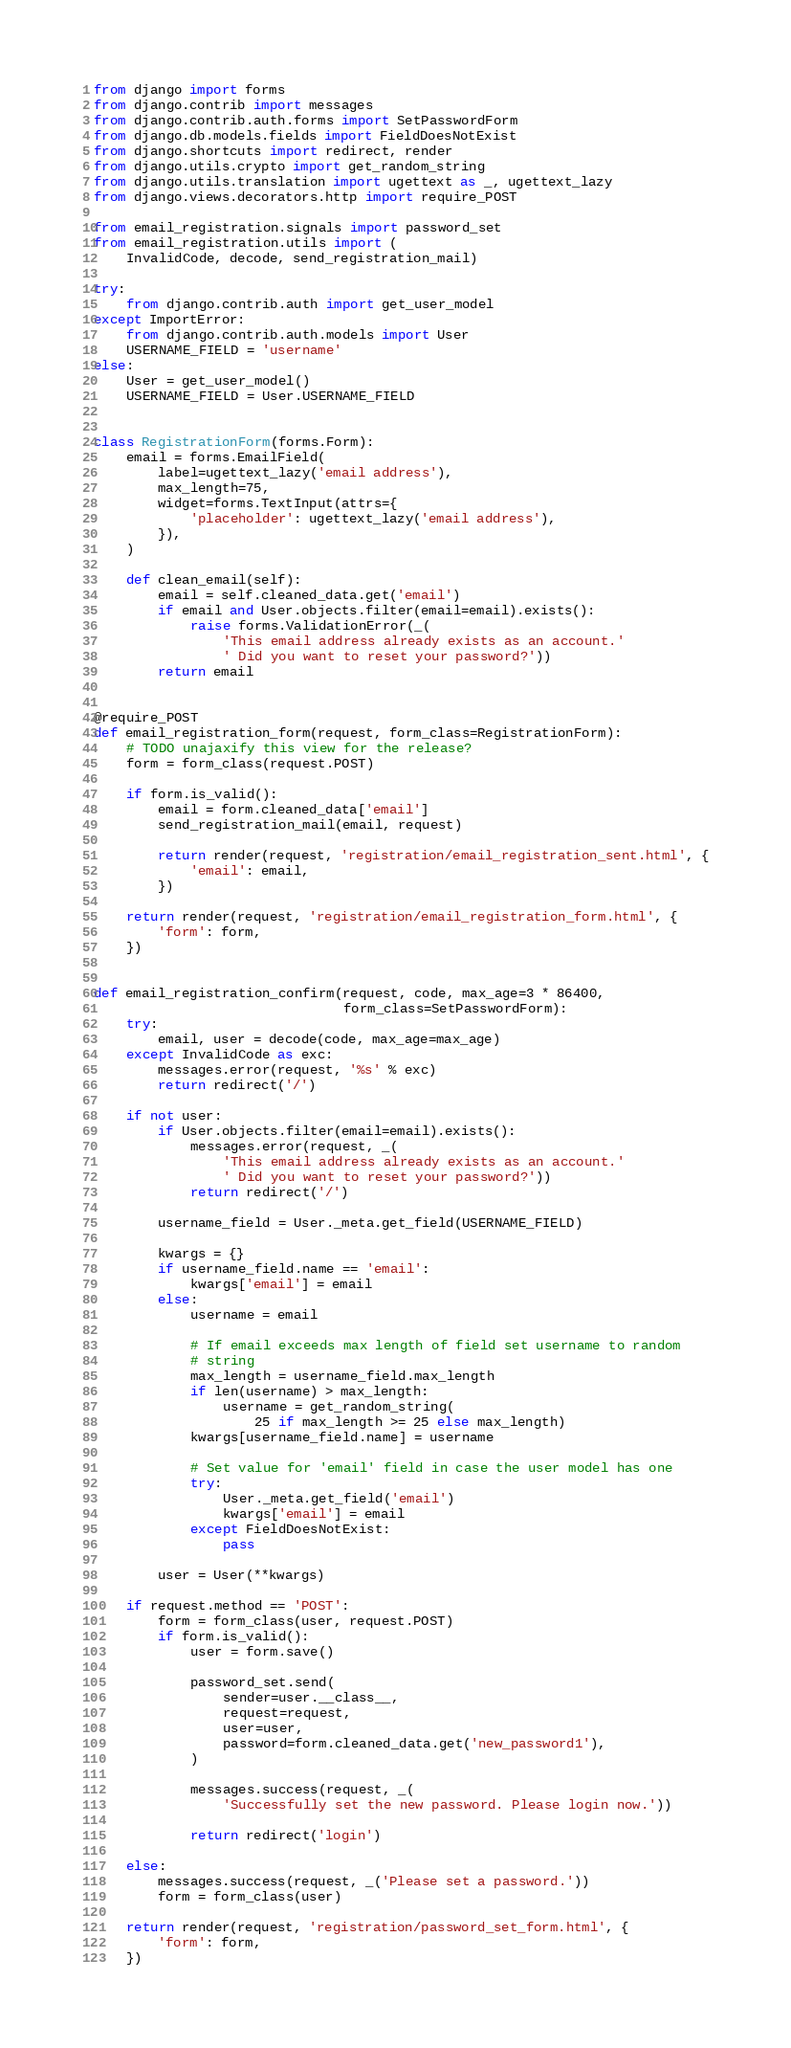<code> <loc_0><loc_0><loc_500><loc_500><_Python_>from django import forms
from django.contrib import messages
from django.contrib.auth.forms import SetPasswordForm
from django.db.models.fields import FieldDoesNotExist
from django.shortcuts import redirect, render
from django.utils.crypto import get_random_string
from django.utils.translation import ugettext as _, ugettext_lazy
from django.views.decorators.http import require_POST

from email_registration.signals import password_set
from email_registration.utils import (
    InvalidCode, decode, send_registration_mail)

try:
    from django.contrib.auth import get_user_model
except ImportError:
    from django.contrib.auth.models import User
    USERNAME_FIELD = 'username'
else:
    User = get_user_model()
    USERNAME_FIELD = User.USERNAME_FIELD


class RegistrationForm(forms.Form):
    email = forms.EmailField(
        label=ugettext_lazy('email address'),
        max_length=75,
        widget=forms.TextInput(attrs={
            'placeholder': ugettext_lazy('email address'),
        }),
    )

    def clean_email(self):
        email = self.cleaned_data.get('email')
        if email and User.objects.filter(email=email).exists():
            raise forms.ValidationError(_(
                'This email address already exists as an account.'
                ' Did you want to reset your password?'))
        return email


@require_POST
def email_registration_form(request, form_class=RegistrationForm):
    # TODO unajaxify this view for the release?
    form = form_class(request.POST)

    if form.is_valid():
        email = form.cleaned_data['email']
        send_registration_mail(email, request)

        return render(request, 'registration/email_registration_sent.html', {
            'email': email,
        })

    return render(request, 'registration/email_registration_form.html', {
        'form': form,
    })


def email_registration_confirm(request, code, max_age=3 * 86400,
                               form_class=SetPasswordForm):
    try:
        email, user = decode(code, max_age=max_age)
    except InvalidCode as exc:
        messages.error(request, '%s' % exc)
        return redirect('/')

    if not user:
        if User.objects.filter(email=email).exists():
            messages.error(request, _(
                'This email address already exists as an account.'
                ' Did you want to reset your password?'))
            return redirect('/')

        username_field = User._meta.get_field(USERNAME_FIELD)

        kwargs = {}
        if username_field.name == 'email':
            kwargs['email'] = email
        else:
            username = email

            # If email exceeds max length of field set username to random
            # string
            max_length = username_field.max_length
            if len(username) > max_length:
                username = get_random_string(
                    25 if max_length >= 25 else max_length)
            kwargs[username_field.name] = username

            # Set value for 'email' field in case the user model has one
            try:
                User._meta.get_field('email')
                kwargs['email'] = email
            except FieldDoesNotExist:
                pass

        user = User(**kwargs)

    if request.method == 'POST':
        form = form_class(user, request.POST)
        if form.is_valid():
            user = form.save()

            password_set.send(
                sender=user.__class__,
                request=request,
                user=user,
                password=form.cleaned_data.get('new_password1'),
            )

            messages.success(request, _(
                'Successfully set the new password. Please login now.'))

            return redirect('login')

    else:
        messages.success(request, _('Please set a password.'))
        form = form_class(user)

    return render(request, 'registration/password_set_form.html', {
        'form': form,
    })
</code> 